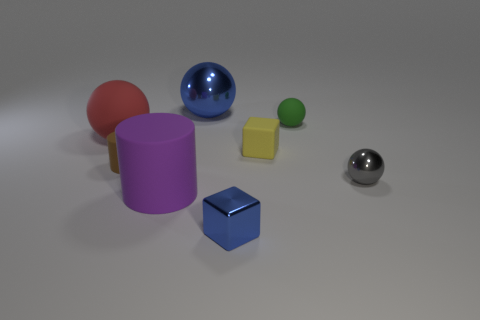Is there any other thing that is the same color as the large metallic thing?
Provide a short and direct response. Yes. There is a large thing that is made of the same material as the blue block; what is its shape?
Give a very brief answer. Sphere. There is a small gray metal object; does it have the same shape as the blue metallic thing behind the tiny metallic block?
Provide a succinct answer. Yes. What material is the thing that is on the right side of the tiny sphere that is behind the tiny metal ball made of?
Offer a terse response. Metal. Is the number of tiny rubber balls in front of the green matte object the same as the number of small green metal blocks?
Provide a succinct answer. Yes. Do the small object that is in front of the purple cylinder and the shiny sphere that is on the left side of the tiny matte cube have the same color?
Your answer should be very brief. Yes. What number of big objects are behind the small brown thing and to the right of the red ball?
Offer a terse response. 1. What number of other things are there of the same shape as the tiny blue thing?
Offer a terse response. 1. Are there more matte things right of the yellow object than big brown metallic cylinders?
Make the answer very short. Yes. The large object that is in front of the tiny metallic sphere is what color?
Offer a terse response. Purple. 